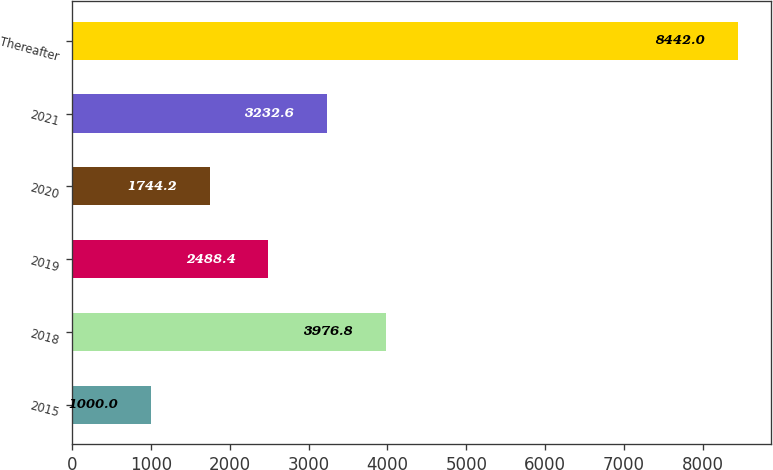<chart> <loc_0><loc_0><loc_500><loc_500><bar_chart><fcel>2015<fcel>2018<fcel>2019<fcel>2020<fcel>2021<fcel>Thereafter<nl><fcel>1000<fcel>3976.8<fcel>2488.4<fcel>1744.2<fcel>3232.6<fcel>8442<nl></chart> 